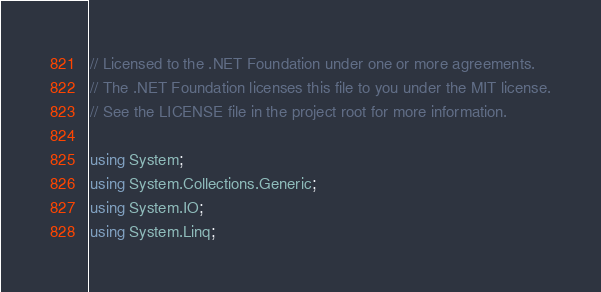<code> <loc_0><loc_0><loc_500><loc_500><_C#_>// Licensed to the .NET Foundation under one or more agreements.
// The .NET Foundation licenses this file to you under the MIT license.
// See the LICENSE file in the project root for more information.

using System;
using System.Collections.Generic;
using System.IO;
using System.Linq;</code> 